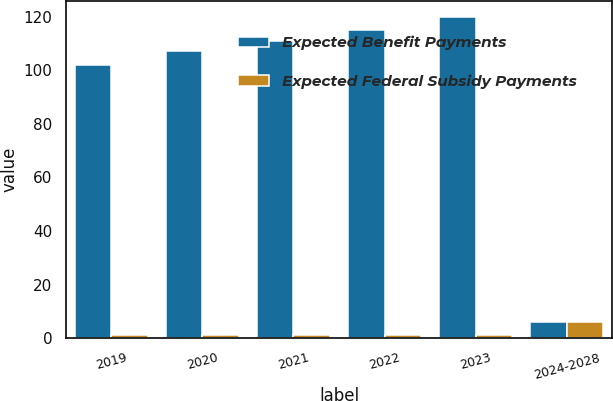Convert chart to OTSL. <chart><loc_0><loc_0><loc_500><loc_500><stacked_bar_chart><ecel><fcel>2019<fcel>2020<fcel>2021<fcel>2022<fcel>2023<fcel>2024-2028<nl><fcel>Expected Benefit Payments<fcel>102<fcel>107<fcel>111<fcel>115<fcel>120<fcel>6<nl><fcel>Expected Federal Subsidy Payments<fcel>1<fcel>1<fcel>1<fcel>1<fcel>1<fcel>6<nl></chart> 